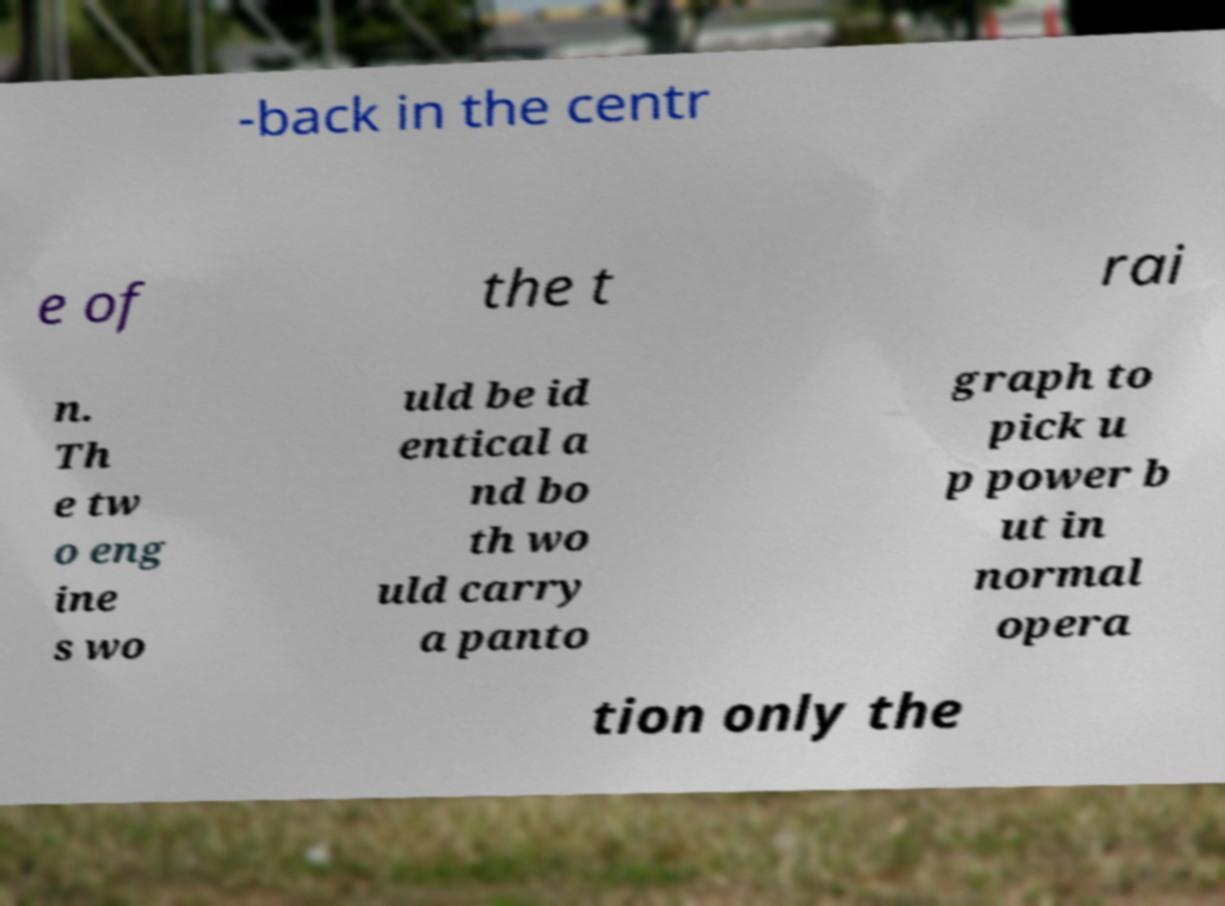Can you read and provide the text displayed in the image?This photo seems to have some interesting text. Can you extract and type it out for me? -back in the centr e of the t rai n. Th e tw o eng ine s wo uld be id entical a nd bo th wo uld carry a panto graph to pick u p power b ut in normal opera tion only the 